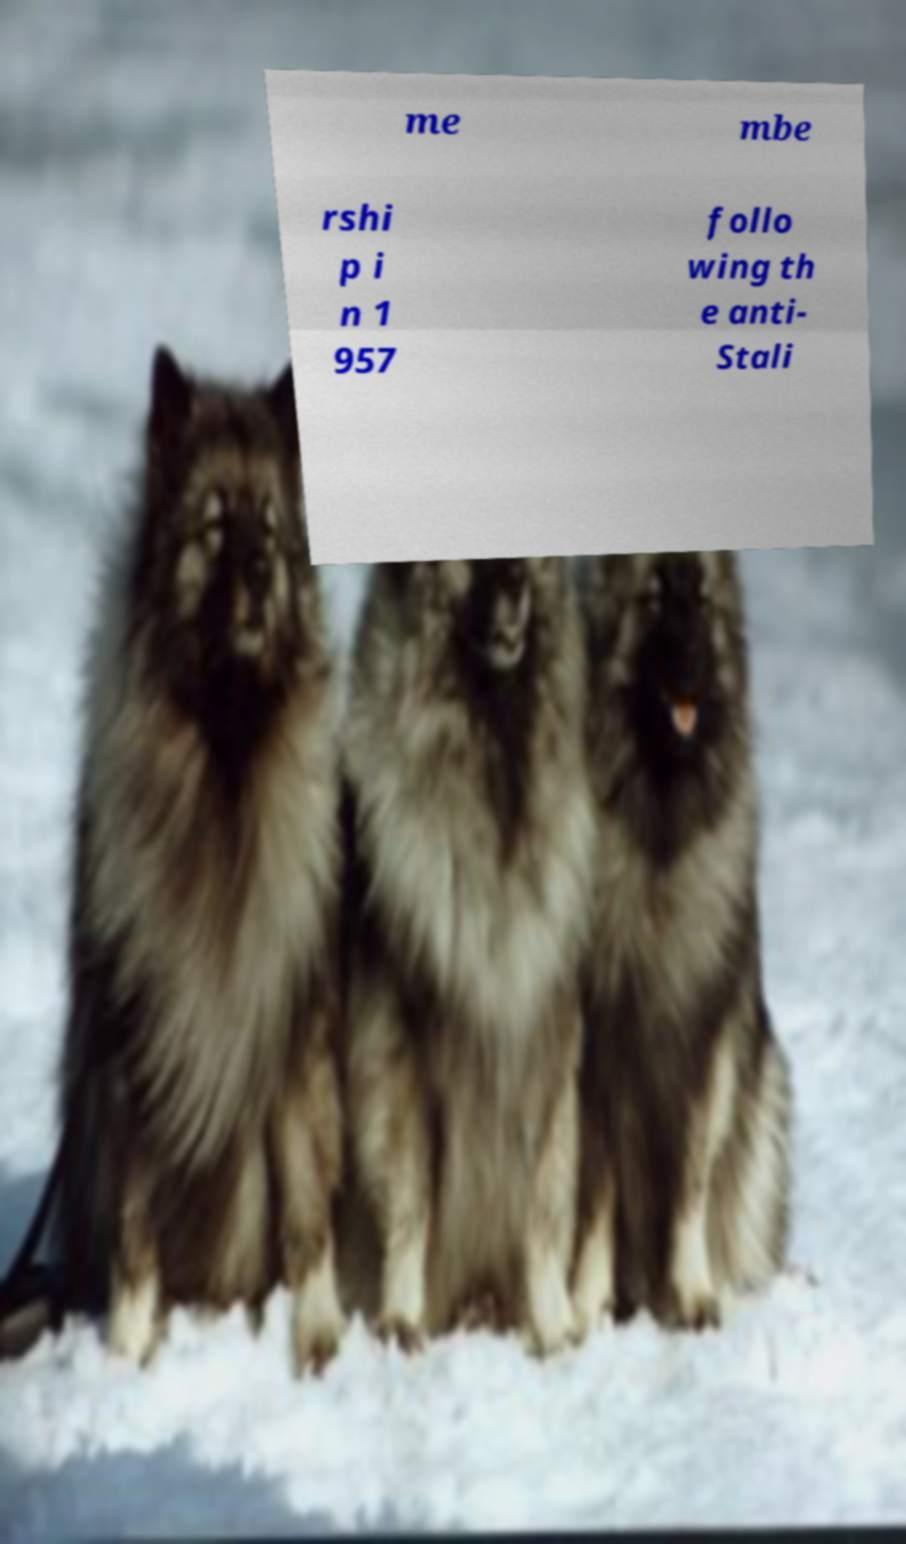Could you extract and type out the text from this image? me mbe rshi p i n 1 957 follo wing th e anti- Stali 